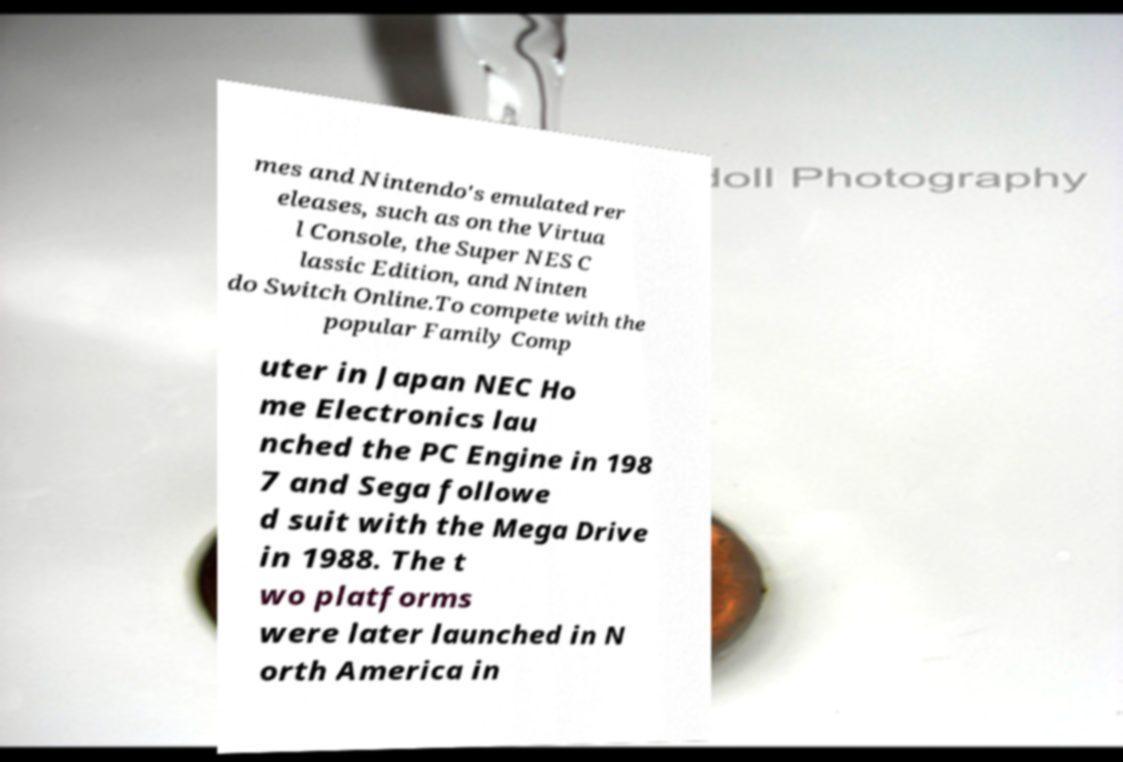I need the written content from this picture converted into text. Can you do that? mes and Nintendo's emulated rer eleases, such as on the Virtua l Console, the Super NES C lassic Edition, and Ninten do Switch Online.To compete with the popular Family Comp uter in Japan NEC Ho me Electronics lau nched the PC Engine in 198 7 and Sega followe d suit with the Mega Drive in 1988. The t wo platforms were later launched in N orth America in 